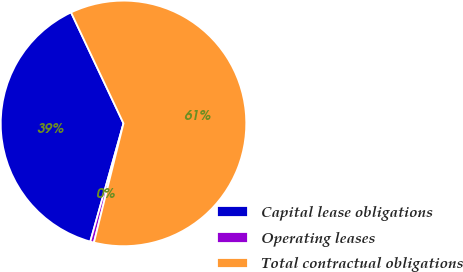Convert chart. <chart><loc_0><loc_0><loc_500><loc_500><pie_chart><fcel>Capital lease obligations<fcel>Operating leases<fcel>Total contractual obligations<nl><fcel>38.61%<fcel>0.49%<fcel>60.9%<nl></chart> 